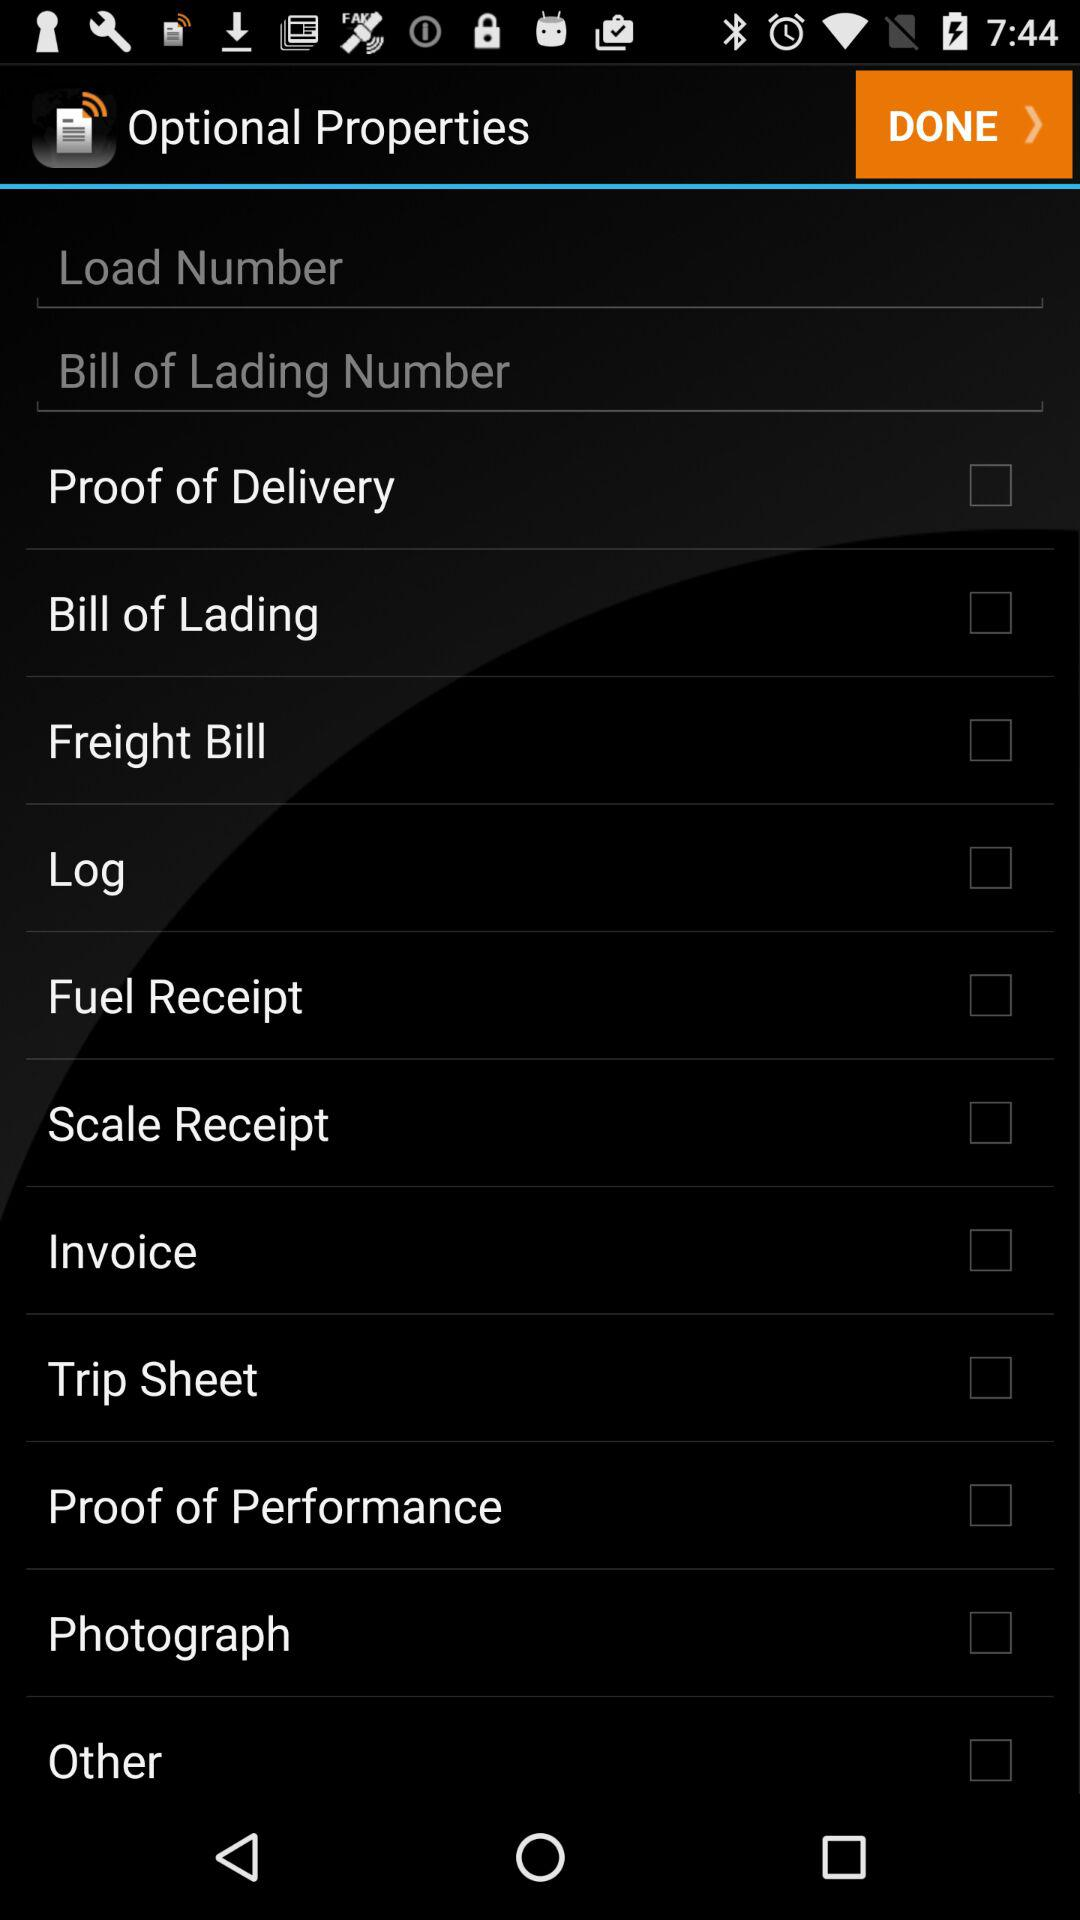What is the status of "Log"? The status of "Log" is "off". 